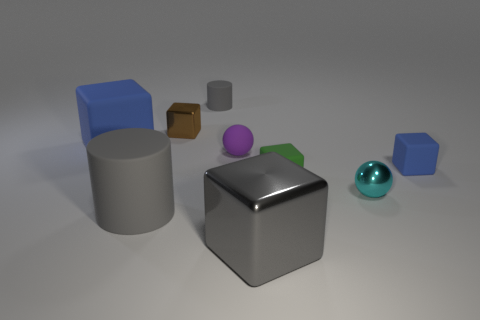How many small matte cylinders are the same color as the matte ball?
Offer a very short reply. 0. How many things are small green matte things or tiny rubber cylinders?
Your answer should be compact. 2. There is a cyan shiny thing that is the same size as the brown block; what is its shape?
Your answer should be compact. Sphere. What number of cubes are both left of the small cyan metallic sphere and behind the metallic ball?
Make the answer very short. 3. What is the tiny block behind the large blue thing made of?
Provide a succinct answer. Metal. What size is the gray thing that is made of the same material as the tiny cyan thing?
Offer a very short reply. Large. There is a blue object that is on the left side of the big metallic cube; is its size the same as the metal block that is on the right side of the tiny gray object?
Keep it short and to the point. Yes. What is the material of the brown thing that is the same size as the cyan sphere?
Ensure brevity in your answer.  Metal. What material is the block that is to the right of the big cylinder and left of the small matte ball?
Provide a short and direct response. Metal. Are any tiny cyan things visible?
Offer a terse response. Yes. 